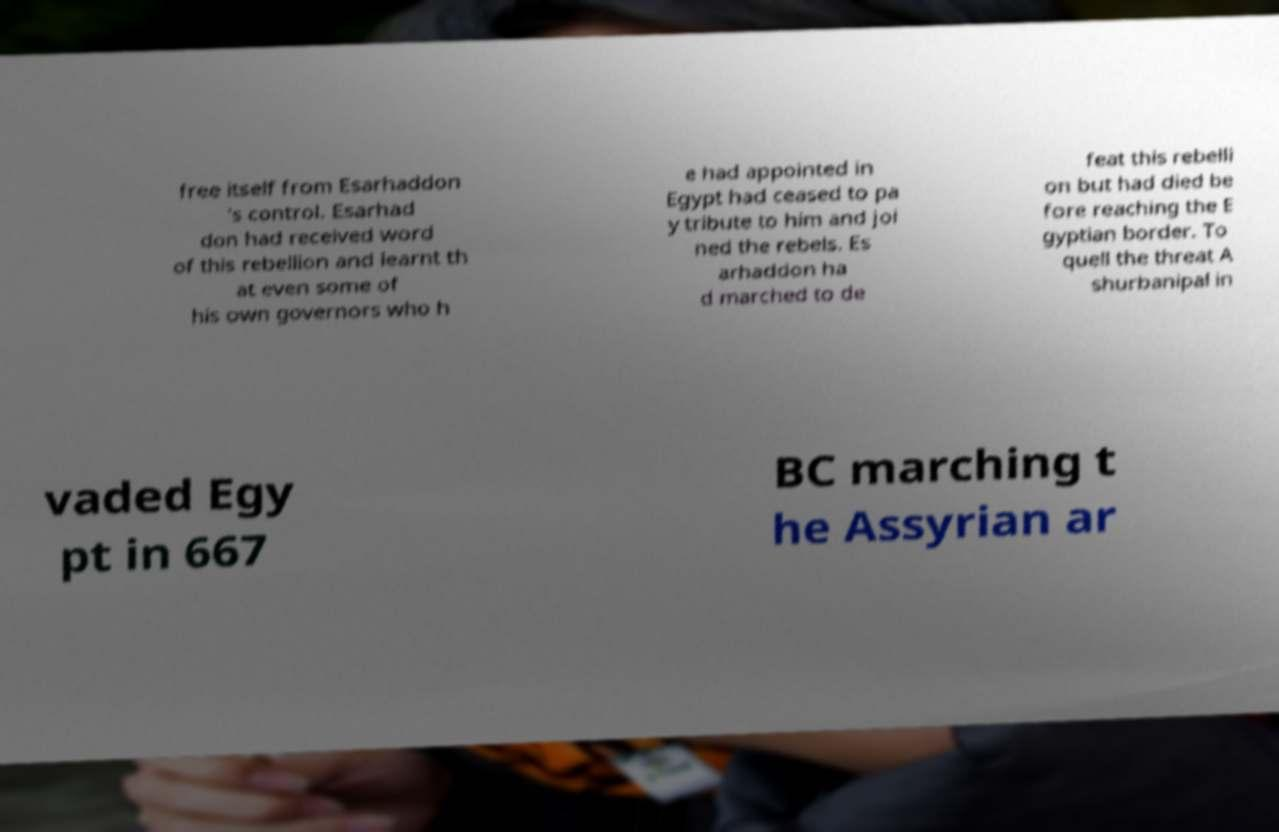Could you assist in decoding the text presented in this image and type it out clearly? free itself from Esarhaddon 's control. Esarhad don had received word of this rebellion and learnt th at even some of his own governors who h e had appointed in Egypt had ceased to pa y tribute to him and joi ned the rebels. Es arhaddon ha d marched to de feat this rebelli on but had died be fore reaching the E gyptian border. To quell the threat A shurbanipal in vaded Egy pt in 667 BC marching t he Assyrian ar 